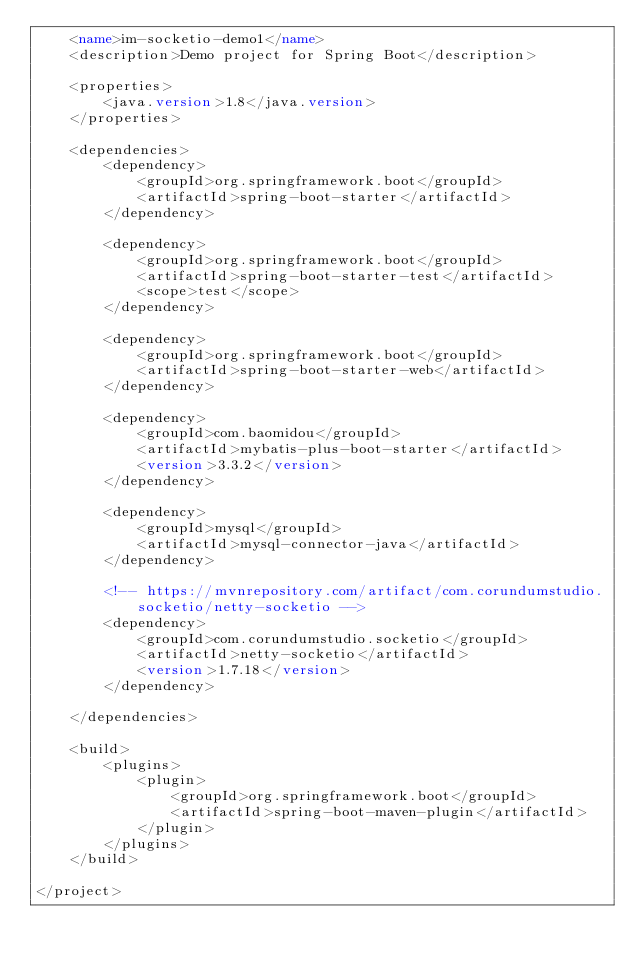Convert code to text. <code><loc_0><loc_0><loc_500><loc_500><_XML_>    <name>im-socketio-demo1</name>
    <description>Demo project for Spring Boot</description>

    <properties>
        <java.version>1.8</java.version>
    </properties>

    <dependencies>
        <dependency>
            <groupId>org.springframework.boot</groupId>
            <artifactId>spring-boot-starter</artifactId>
        </dependency>

        <dependency>
            <groupId>org.springframework.boot</groupId>
            <artifactId>spring-boot-starter-test</artifactId>
            <scope>test</scope>
        </dependency>

        <dependency>
            <groupId>org.springframework.boot</groupId>
            <artifactId>spring-boot-starter-web</artifactId>
        </dependency>

        <dependency>
            <groupId>com.baomidou</groupId>
            <artifactId>mybatis-plus-boot-starter</artifactId>
            <version>3.3.2</version>
        </dependency>

        <dependency>
            <groupId>mysql</groupId>
            <artifactId>mysql-connector-java</artifactId>
        </dependency>

        <!-- https://mvnrepository.com/artifact/com.corundumstudio.socketio/netty-socketio -->
        <dependency>
            <groupId>com.corundumstudio.socketio</groupId>
            <artifactId>netty-socketio</artifactId>
            <version>1.7.18</version>
        </dependency>

    </dependencies>

    <build>
        <plugins>
            <plugin>
                <groupId>org.springframework.boot</groupId>
                <artifactId>spring-boot-maven-plugin</artifactId>
            </plugin>
        </plugins>
    </build>

</project>
</code> 